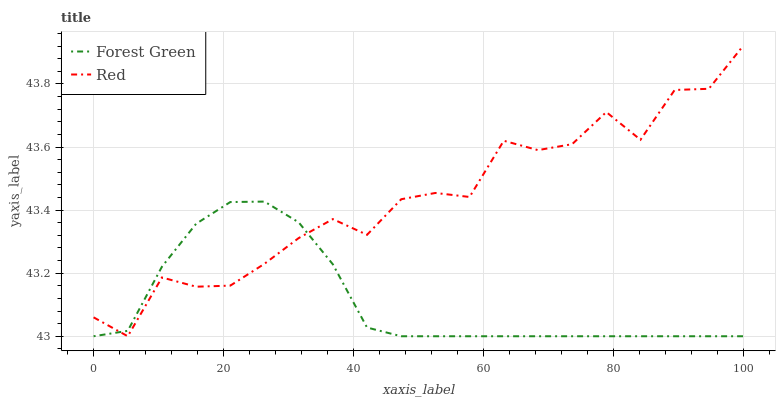Does Forest Green have the minimum area under the curve?
Answer yes or no. Yes. Does Red have the maximum area under the curve?
Answer yes or no. Yes. Does Red have the minimum area under the curve?
Answer yes or no. No. Is Forest Green the smoothest?
Answer yes or no. Yes. Is Red the roughest?
Answer yes or no. Yes. Is Red the smoothest?
Answer yes or no. No. Does Forest Green have the lowest value?
Answer yes or no. Yes. Does Red have the highest value?
Answer yes or no. Yes. Does Red intersect Forest Green?
Answer yes or no. Yes. Is Red less than Forest Green?
Answer yes or no. No. Is Red greater than Forest Green?
Answer yes or no. No. 